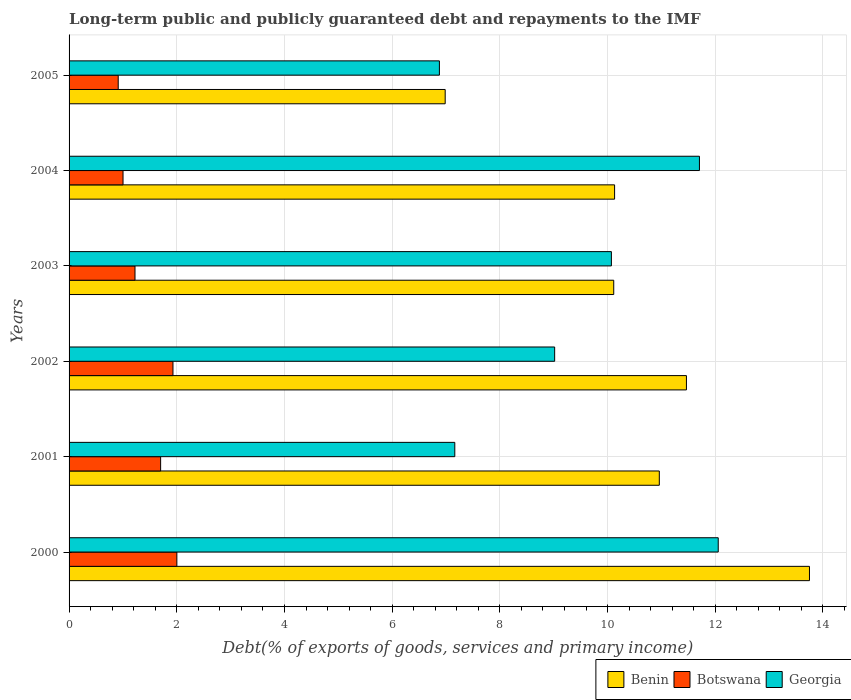How many groups of bars are there?
Ensure brevity in your answer.  6. Are the number of bars on each tick of the Y-axis equal?
Ensure brevity in your answer.  Yes. How many bars are there on the 3rd tick from the top?
Provide a succinct answer. 3. In how many cases, is the number of bars for a given year not equal to the number of legend labels?
Ensure brevity in your answer.  0. What is the debt and repayments in Botswana in 2004?
Provide a succinct answer. 1. Across all years, what is the maximum debt and repayments in Georgia?
Provide a short and direct response. 12.06. Across all years, what is the minimum debt and repayments in Benin?
Offer a very short reply. 6.99. What is the total debt and repayments in Botswana in the graph?
Provide a succinct answer. 8.77. What is the difference between the debt and repayments in Benin in 2004 and that in 2005?
Offer a very short reply. 3.15. What is the difference between the debt and repayments in Benin in 2000 and the debt and repayments in Botswana in 2002?
Ensure brevity in your answer.  11.82. What is the average debt and repayments in Georgia per year?
Offer a very short reply. 9.48. In the year 2003, what is the difference between the debt and repayments in Botswana and debt and repayments in Georgia?
Provide a short and direct response. -8.85. In how many years, is the debt and repayments in Botswana greater than 9.2 %?
Your answer should be very brief. 0. What is the ratio of the debt and repayments in Benin in 2000 to that in 2002?
Ensure brevity in your answer.  1.2. Is the debt and repayments in Georgia in 2003 less than that in 2005?
Provide a short and direct response. No. Is the difference between the debt and repayments in Botswana in 2002 and 2005 greater than the difference between the debt and repayments in Georgia in 2002 and 2005?
Make the answer very short. No. What is the difference between the highest and the second highest debt and repayments in Benin?
Ensure brevity in your answer.  2.28. What is the difference between the highest and the lowest debt and repayments in Botswana?
Your response must be concise. 1.09. What does the 2nd bar from the top in 2005 represents?
Provide a short and direct response. Botswana. What does the 1st bar from the bottom in 2000 represents?
Ensure brevity in your answer.  Benin. What is the difference between two consecutive major ticks on the X-axis?
Offer a terse response. 2. Does the graph contain any zero values?
Your response must be concise. No. Does the graph contain grids?
Provide a succinct answer. Yes. Where does the legend appear in the graph?
Your response must be concise. Bottom right. How many legend labels are there?
Make the answer very short. 3. How are the legend labels stacked?
Give a very brief answer. Horizontal. What is the title of the graph?
Keep it short and to the point. Long-term public and publicly guaranteed debt and repayments to the IMF. Does "Qatar" appear as one of the legend labels in the graph?
Your answer should be compact. No. What is the label or title of the X-axis?
Make the answer very short. Debt(% of exports of goods, services and primary income). What is the label or title of the Y-axis?
Your answer should be compact. Years. What is the Debt(% of exports of goods, services and primary income) of Benin in 2000?
Your answer should be very brief. 13.75. What is the Debt(% of exports of goods, services and primary income) in Botswana in 2000?
Keep it short and to the point. 2. What is the Debt(% of exports of goods, services and primary income) of Georgia in 2000?
Provide a succinct answer. 12.06. What is the Debt(% of exports of goods, services and primary income) in Benin in 2001?
Offer a very short reply. 10.96. What is the Debt(% of exports of goods, services and primary income) of Botswana in 2001?
Your answer should be compact. 1.7. What is the Debt(% of exports of goods, services and primary income) of Georgia in 2001?
Your response must be concise. 7.16. What is the Debt(% of exports of goods, services and primary income) in Benin in 2002?
Ensure brevity in your answer.  11.47. What is the Debt(% of exports of goods, services and primary income) in Botswana in 2002?
Give a very brief answer. 1.93. What is the Debt(% of exports of goods, services and primary income) in Georgia in 2002?
Keep it short and to the point. 9.02. What is the Debt(% of exports of goods, services and primary income) in Benin in 2003?
Your answer should be compact. 10.12. What is the Debt(% of exports of goods, services and primary income) of Botswana in 2003?
Make the answer very short. 1.22. What is the Debt(% of exports of goods, services and primary income) in Georgia in 2003?
Make the answer very short. 10.07. What is the Debt(% of exports of goods, services and primary income) of Benin in 2004?
Keep it short and to the point. 10.13. What is the Debt(% of exports of goods, services and primary income) of Botswana in 2004?
Give a very brief answer. 1. What is the Debt(% of exports of goods, services and primary income) of Georgia in 2004?
Provide a short and direct response. 11.71. What is the Debt(% of exports of goods, services and primary income) of Benin in 2005?
Offer a terse response. 6.99. What is the Debt(% of exports of goods, services and primary income) in Botswana in 2005?
Offer a very short reply. 0.91. What is the Debt(% of exports of goods, services and primary income) in Georgia in 2005?
Your response must be concise. 6.88. Across all years, what is the maximum Debt(% of exports of goods, services and primary income) of Benin?
Ensure brevity in your answer.  13.75. Across all years, what is the maximum Debt(% of exports of goods, services and primary income) of Botswana?
Offer a very short reply. 2. Across all years, what is the maximum Debt(% of exports of goods, services and primary income) of Georgia?
Keep it short and to the point. 12.06. Across all years, what is the minimum Debt(% of exports of goods, services and primary income) in Benin?
Provide a short and direct response. 6.99. Across all years, what is the minimum Debt(% of exports of goods, services and primary income) of Botswana?
Offer a very short reply. 0.91. Across all years, what is the minimum Debt(% of exports of goods, services and primary income) in Georgia?
Your response must be concise. 6.88. What is the total Debt(% of exports of goods, services and primary income) in Benin in the graph?
Ensure brevity in your answer.  63.41. What is the total Debt(% of exports of goods, services and primary income) in Botswana in the graph?
Your answer should be very brief. 8.77. What is the total Debt(% of exports of goods, services and primary income) in Georgia in the graph?
Provide a short and direct response. 56.89. What is the difference between the Debt(% of exports of goods, services and primary income) of Benin in 2000 and that in 2001?
Offer a very short reply. 2.79. What is the difference between the Debt(% of exports of goods, services and primary income) of Botswana in 2000 and that in 2001?
Make the answer very short. 0.3. What is the difference between the Debt(% of exports of goods, services and primary income) in Georgia in 2000 and that in 2001?
Offer a terse response. 4.89. What is the difference between the Debt(% of exports of goods, services and primary income) in Benin in 2000 and that in 2002?
Your answer should be very brief. 2.28. What is the difference between the Debt(% of exports of goods, services and primary income) in Botswana in 2000 and that in 2002?
Provide a succinct answer. 0.07. What is the difference between the Debt(% of exports of goods, services and primary income) in Georgia in 2000 and that in 2002?
Your answer should be compact. 3.04. What is the difference between the Debt(% of exports of goods, services and primary income) of Benin in 2000 and that in 2003?
Give a very brief answer. 3.63. What is the difference between the Debt(% of exports of goods, services and primary income) of Botswana in 2000 and that in 2003?
Offer a terse response. 0.78. What is the difference between the Debt(% of exports of goods, services and primary income) of Georgia in 2000 and that in 2003?
Give a very brief answer. 1.98. What is the difference between the Debt(% of exports of goods, services and primary income) in Benin in 2000 and that in 2004?
Keep it short and to the point. 3.62. What is the difference between the Debt(% of exports of goods, services and primary income) in Georgia in 2000 and that in 2004?
Provide a succinct answer. 0.35. What is the difference between the Debt(% of exports of goods, services and primary income) in Benin in 2000 and that in 2005?
Provide a succinct answer. 6.76. What is the difference between the Debt(% of exports of goods, services and primary income) of Botswana in 2000 and that in 2005?
Provide a succinct answer. 1.09. What is the difference between the Debt(% of exports of goods, services and primary income) in Georgia in 2000 and that in 2005?
Give a very brief answer. 5.18. What is the difference between the Debt(% of exports of goods, services and primary income) of Benin in 2001 and that in 2002?
Provide a succinct answer. -0.5. What is the difference between the Debt(% of exports of goods, services and primary income) in Botswana in 2001 and that in 2002?
Offer a terse response. -0.23. What is the difference between the Debt(% of exports of goods, services and primary income) in Georgia in 2001 and that in 2002?
Your answer should be compact. -1.85. What is the difference between the Debt(% of exports of goods, services and primary income) in Benin in 2001 and that in 2003?
Give a very brief answer. 0.85. What is the difference between the Debt(% of exports of goods, services and primary income) of Botswana in 2001 and that in 2003?
Keep it short and to the point. 0.48. What is the difference between the Debt(% of exports of goods, services and primary income) in Georgia in 2001 and that in 2003?
Your answer should be very brief. -2.91. What is the difference between the Debt(% of exports of goods, services and primary income) of Benin in 2001 and that in 2004?
Offer a very short reply. 0.83. What is the difference between the Debt(% of exports of goods, services and primary income) of Botswana in 2001 and that in 2004?
Your response must be concise. 0.7. What is the difference between the Debt(% of exports of goods, services and primary income) in Georgia in 2001 and that in 2004?
Offer a very short reply. -4.54. What is the difference between the Debt(% of exports of goods, services and primary income) in Benin in 2001 and that in 2005?
Provide a succinct answer. 3.98. What is the difference between the Debt(% of exports of goods, services and primary income) in Botswana in 2001 and that in 2005?
Your answer should be compact. 0.79. What is the difference between the Debt(% of exports of goods, services and primary income) in Georgia in 2001 and that in 2005?
Your answer should be very brief. 0.29. What is the difference between the Debt(% of exports of goods, services and primary income) in Benin in 2002 and that in 2003?
Give a very brief answer. 1.35. What is the difference between the Debt(% of exports of goods, services and primary income) of Botswana in 2002 and that in 2003?
Offer a terse response. 0.71. What is the difference between the Debt(% of exports of goods, services and primary income) in Georgia in 2002 and that in 2003?
Offer a terse response. -1.05. What is the difference between the Debt(% of exports of goods, services and primary income) of Benin in 2002 and that in 2004?
Your answer should be compact. 1.33. What is the difference between the Debt(% of exports of goods, services and primary income) of Botswana in 2002 and that in 2004?
Offer a terse response. 0.93. What is the difference between the Debt(% of exports of goods, services and primary income) in Georgia in 2002 and that in 2004?
Offer a terse response. -2.69. What is the difference between the Debt(% of exports of goods, services and primary income) in Benin in 2002 and that in 2005?
Your response must be concise. 4.48. What is the difference between the Debt(% of exports of goods, services and primary income) of Botswana in 2002 and that in 2005?
Your answer should be very brief. 1.02. What is the difference between the Debt(% of exports of goods, services and primary income) of Georgia in 2002 and that in 2005?
Keep it short and to the point. 2.14. What is the difference between the Debt(% of exports of goods, services and primary income) of Benin in 2003 and that in 2004?
Your answer should be very brief. -0.02. What is the difference between the Debt(% of exports of goods, services and primary income) in Botswana in 2003 and that in 2004?
Offer a very short reply. 0.22. What is the difference between the Debt(% of exports of goods, services and primary income) in Georgia in 2003 and that in 2004?
Offer a very short reply. -1.64. What is the difference between the Debt(% of exports of goods, services and primary income) in Benin in 2003 and that in 2005?
Offer a terse response. 3.13. What is the difference between the Debt(% of exports of goods, services and primary income) of Botswana in 2003 and that in 2005?
Your response must be concise. 0.31. What is the difference between the Debt(% of exports of goods, services and primary income) in Georgia in 2003 and that in 2005?
Offer a very short reply. 3.19. What is the difference between the Debt(% of exports of goods, services and primary income) of Benin in 2004 and that in 2005?
Provide a succinct answer. 3.15. What is the difference between the Debt(% of exports of goods, services and primary income) of Botswana in 2004 and that in 2005?
Provide a succinct answer. 0.09. What is the difference between the Debt(% of exports of goods, services and primary income) of Georgia in 2004 and that in 2005?
Ensure brevity in your answer.  4.83. What is the difference between the Debt(% of exports of goods, services and primary income) in Benin in 2000 and the Debt(% of exports of goods, services and primary income) in Botswana in 2001?
Keep it short and to the point. 12.05. What is the difference between the Debt(% of exports of goods, services and primary income) of Benin in 2000 and the Debt(% of exports of goods, services and primary income) of Georgia in 2001?
Keep it short and to the point. 6.59. What is the difference between the Debt(% of exports of goods, services and primary income) in Botswana in 2000 and the Debt(% of exports of goods, services and primary income) in Georgia in 2001?
Make the answer very short. -5.16. What is the difference between the Debt(% of exports of goods, services and primary income) of Benin in 2000 and the Debt(% of exports of goods, services and primary income) of Botswana in 2002?
Your response must be concise. 11.82. What is the difference between the Debt(% of exports of goods, services and primary income) in Benin in 2000 and the Debt(% of exports of goods, services and primary income) in Georgia in 2002?
Provide a short and direct response. 4.73. What is the difference between the Debt(% of exports of goods, services and primary income) in Botswana in 2000 and the Debt(% of exports of goods, services and primary income) in Georgia in 2002?
Your response must be concise. -7.02. What is the difference between the Debt(% of exports of goods, services and primary income) in Benin in 2000 and the Debt(% of exports of goods, services and primary income) in Botswana in 2003?
Offer a terse response. 12.53. What is the difference between the Debt(% of exports of goods, services and primary income) of Benin in 2000 and the Debt(% of exports of goods, services and primary income) of Georgia in 2003?
Provide a short and direct response. 3.68. What is the difference between the Debt(% of exports of goods, services and primary income) of Botswana in 2000 and the Debt(% of exports of goods, services and primary income) of Georgia in 2003?
Your answer should be compact. -8.07. What is the difference between the Debt(% of exports of goods, services and primary income) in Benin in 2000 and the Debt(% of exports of goods, services and primary income) in Botswana in 2004?
Provide a succinct answer. 12.75. What is the difference between the Debt(% of exports of goods, services and primary income) of Benin in 2000 and the Debt(% of exports of goods, services and primary income) of Georgia in 2004?
Your answer should be compact. 2.04. What is the difference between the Debt(% of exports of goods, services and primary income) of Botswana in 2000 and the Debt(% of exports of goods, services and primary income) of Georgia in 2004?
Make the answer very short. -9.71. What is the difference between the Debt(% of exports of goods, services and primary income) in Benin in 2000 and the Debt(% of exports of goods, services and primary income) in Botswana in 2005?
Make the answer very short. 12.84. What is the difference between the Debt(% of exports of goods, services and primary income) of Benin in 2000 and the Debt(% of exports of goods, services and primary income) of Georgia in 2005?
Provide a succinct answer. 6.87. What is the difference between the Debt(% of exports of goods, services and primary income) of Botswana in 2000 and the Debt(% of exports of goods, services and primary income) of Georgia in 2005?
Keep it short and to the point. -4.88. What is the difference between the Debt(% of exports of goods, services and primary income) of Benin in 2001 and the Debt(% of exports of goods, services and primary income) of Botswana in 2002?
Ensure brevity in your answer.  9.03. What is the difference between the Debt(% of exports of goods, services and primary income) in Benin in 2001 and the Debt(% of exports of goods, services and primary income) in Georgia in 2002?
Keep it short and to the point. 1.94. What is the difference between the Debt(% of exports of goods, services and primary income) of Botswana in 2001 and the Debt(% of exports of goods, services and primary income) of Georgia in 2002?
Keep it short and to the point. -7.32. What is the difference between the Debt(% of exports of goods, services and primary income) of Benin in 2001 and the Debt(% of exports of goods, services and primary income) of Botswana in 2003?
Your answer should be very brief. 9.74. What is the difference between the Debt(% of exports of goods, services and primary income) of Benin in 2001 and the Debt(% of exports of goods, services and primary income) of Georgia in 2003?
Give a very brief answer. 0.89. What is the difference between the Debt(% of exports of goods, services and primary income) in Botswana in 2001 and the Debt(% of exports of goods, services and primary income) in Georgia in 2003?
Give a very brief answer. -8.37. What is the difference between the Debt(% of exports of goods, services and primary income) in Benin in 2001 and the Debt(% of exports of goods, services and primary income) in Botswana in 2004?
Your answer should be compact. 9.96. What is the difference between the Debt(% of exports of goods, services and primary income) of Benin in 2001 and the Debt(% of exports of goods, services and primary income) of Georgia in 2004?
Make the answer very short. -0.75. What is the difference between the Debt(% of exports of goods, services and primary income) of Botswana in 2001 and the Debt(% of exports of goods, services and primary income) of Georgia in 2004?
Keep it short and to the point. -10.01. What is the difference between the Debt(% of exports of goods, services and primary income) in Benin in 2001 and the Debt(% of exports of goods, services and primary income) in Botswana in 2005?
Ensure brevity in your answer.  10.05. What is the difference between the Debt(% of exports of goods, services and primary income) of Benin in 2001 and the Debt(% of exports of goods, services and primary income) of Georgia in 2005?
Offer a very short reply. 4.08. What is the difference between the Debt(% of exports of goods, services and primary income) in Botswana in 2001 and the Debt(% of exports of goods, services and primary income) in Georgia in 2005?
Your response must be concise. -5.18. What is the difference between the Debt(% of exports of goods, services and primary income) of Benin in 2002 and the Debt(% of exports of goods, services and primary income) of Botswana in 2003?
Offer a very short reply. 10.24. What is the difference between the Debt(% of exports of goods, services and primary income) in Benin in 2002 and the Debt(% of exports of goods, services and primary income) in Georgia in 2003?
Ensure brevity in your answer.  1.39. What is the difference between the Debt(% of exports of goods, services and primary income) in Botswana in 2002 and the Debt(% of exports of goods, services and primary income) in Georgia in 2003?
Keep it short and to the point. -8.14. What is the difference between the Debt(% of exports of goods, services and primary income) of Benin in 2002 and the Debt(% of exports of goods, services and primary income) of Botswana in 2004?
Your answer should be compact. 10.46. What is the difference between the Debt(% of exports of goods, services and primary income) in Benin in 2002 and the Debt(% of exports of goods, services and primary income) in Georgia in 2004?
Provide a short and direct response. -0.24. What is the difference between the Debt(% of exports of goods, services and primary income) of Botswana in 2002 and the Debt(% of exports of goods, services and primary income) of Georgia in 2004?
Your answer should be compact. -9.78. What is the difference between the Debt(% of exports of goods, services and primary income) of Benin in 2002 and the Debt(% of exports of goods, services and primary income) of Botswana in 2005?
Offer a terse response. 10.55. What is the difference between the Debt(% of exports of goods, services and primary income) in Benin in 2002 and the Debt(% of exports of goods, services and primary income) in Georgia in 2005?
Your answer should be compact. 4.59. What is the difference between the Debt(% of exports of goods, services and primary income) in Botswana in 2002 and the Debt(% of exports of goods, services and primary income) in Georgia in 2005?
Your response must be concise. -4.95. What is the difference between the Debt(% of exports of goods, services and primary income) of Benin in 2003 and the Debt(% of exports of goods, services and primary income) of Botswana in 2004?
Provide a succinct answer. 9.11. What is the difference between the Debt(% of exports of goods, services and primary income) in Benin in 2003 and the Debt(% of exports of goods, services and primary income) in Georgia in 2004?
Provide a short and direct response. -1.59. What is the difference between the Debt(% of exports of goods, services and primary income) in Botswana in 2003 and the Debt(% of exports of goods, services and primary income) in Georgia in 2004?
Your answer should be very brief. -10.48. What is the difference between the Debt(% of exports of goods, services and primary income) of Benin in 2003 and the Debt(% of exports of goods, services and primary income) of Botswana in 2005?
Provide a succinct answer. 9.2. What is the difference between the Debt(% of exports of goods, services and primary income) of Benin in 2003 and the Debt(% of exports of goods, services and primary income) of Georgia in 2005?
Your response must be concise. 3.24. What is the difference between the Debt(% of exports of goods, services and primary income) in Botswana in 2003 and the Debt(% of exports of goods, services and primary income) in Georgia in 2005?
Your answer should be compact. -5.65. What is the difference between the Debt(% of exports of goods, services and primary income) of Benin in 2004 and the Debt(% of exports of goods, services and primary income) of Botswana in 2005?
Provide a succinct answer. 9.22. What is the difference between the Debt(% of exports of goods, services and primary income) in Benin in 2004 and the Debt(% of exports of goods, services and primary income) in Georgia in 2005?
Ensure brevity in your answer.  3.25. What is the difference between the Debt(% of exports of goods, services and primary income) in Botswana in 2004 and the Debt(% of exports of goods, services and primary income) in Georgia in 2005?
Your response must be concise. -5.88. What is the average Debt(% of exports of goods, services and primary income) of Benin per year?
Your answer should be compact. 10.57. What is the average Debt(% of exports of goods, services and primary income) in Botswana per year?
Provide a short and direct response. 1.46. What is the average Debt(% of exports of goods, services and primary income) of Georgia per year?
Ensure brevity in your answer.  9.48. In the year 2000, what is the difference between the Debt(% of exports of goods, services and primary income) of Benin and Debt(% of exports of goods, services and primary income) of Botswana?
Offer a terse response. 11.75. In the year 2000, what is the difference between the Debt(% of exports of goods, services and primary income) of Benin and Debt(% of exports of goods, services and primary income) of Georgia?
Your response must be concise. 1.69. In the year 2000, what is the difference between the Debt(% of exports of goods, services and primary income) of Botswana and Debt(% of exports of goods, services and primary income) of Georgia?
Give a very brief answer. -10.05. In the year 2001, what is the difference between the Debt(% of exports of goods, services and primary income) of Benin and Debt(% of exports of goods, services and primary income) of Botswana?
Offer a terse response. 9.26. In the year 2001, what is the difference between the Debt(% of exports of goods, services and primary income) in Benin and Debt(% of exports of goods, services and primary income) in Georgia?
Provide a succinct answer. 3.8. In the year 2001, what is the difference between the Debt(% of exports of goods, services and primary income) in Botswana and Debt(% of exports of goods, services and primary income) in Georgia?
Your answer should be compact. -5.46. In the year 2002, what is the difference between the Debt(% of exports of goods, services and primary income) in Benin and Debt(% of exports of goods, services and primary income) in Botswana?
Provide a succinct answer. 9.54. In the year 2002, what is the difference between the Debt(% of exports of goods, services and primary income) of Benin and Debt(% of exports of goods, services and primary income) of Georgia?
Provide a short and direct response. 2.45. In the year 2002, what is the difference between the Debt(% of exports of goods, services and primary income) of Botswana and Debt(% of exports of goods, services and primary income) of Georgia?
Your answer should be very brief. -7.09. In the year 2003, what is the difference between the Debt(% of exports of goods, services and primary income) of Benin and Debt(% of exports of goods, services and primary income) of Botswana?
Ensure brevity in your answer.  8.89. In the year 2003, what is the difference between the Debt(% of exports of goods, services and primary income) in Benin and Debt(% of exports of goods, services and primary income) in Georgia?
Make the answer very short. 0.04. In the year 2003, what is the difference between the Debt(% of exports of goods, services and primary income) of Botswana and Debt(% of exports of goods, services and primary income) of Georgia?
Keep it short and to the point. -8.85. In the year 2004, what is the difference between the Debt(% of exports of goods, services and primary income) in Benin and Debt(% of exports of goods, services and primary income) in Botswana?
Provide a succinct answer. 9.13. In the year 2004, what is the difference between the Debt(% of exports of goods, services and primary income) of Benin and Debt(% of exports of goods, services and primary income) of Georgia?
Provide a succinct answer. -1.58. In the year 2004, what is the difference between the Debt(% of exports of goods, services and primary income) of Botswana and Debt(% of exports of goods, services and primary income) of Georgia?
Your response must be concise. -10.7. In the year 2005, what is the difference between the Debt(% of exports of goods, services and primary income) in Benin and Debt(% of exports of goods, services and primary income) in Botswana?
Offer a terse response. 6.07. In the year 2005, what is the difference between the Debt(% of exports of goods, services and primary income) of Benin and Debt(% of exports of goods, services and primary income) of Georgia?
Make the answer very short. 0.11. In the year 2005, what is the difference between the Debt(% of exports of goods, services and primary income) of Botswana and Debt(% of exports of goods, services and primary income) of Georgia?
Ensure brevity in your answer.  -5.96. What is the ratio of the Debt(% of exports of goods, services and primary income) in Benin in 2000 to that in 2001?
Offer a very short reply. 1.25. What is the ratio of the Debt(% of exports of goods, services and primary income) of Botswana in 2000 to that in 2001?
Your answer should be compact. 1.18. What is the ratio of the Debt(% of exports of goods, services and primary income) in Georgia in 2000 to that in 2001?
Provide a short and direct response. 1.68. What is the ratio of the Debt(% of exports of goods, services and primary income) in Benin in 2000 to that in 2002?
Make the answer very short. 1.2. What is the ratio of the Debt(% of exports of goods, services and primary income) in Botswana in 2000 to that in 2002?
Your answer should be compact. 1.04. What is the ratio of the Debt(% of exports of goods, services and primary income) of Georgia in 2000 to that in 2002?
Your answer should be compact. 1.34. What is the ratio of the Debt(% of exports of goods, services and primary income) of Benin in 2000 to that in 2003?
Your response must be concise. 1.36. What is the ratio of the Debt(% of exports of goods, services and primary income) of Botswana in 2000 to that in 2003?
Keep it short and to the point. 1.63. What is the ratio of the Debt(% of exports of goods, services and primary income) in Georgia in 2000 to that in 2003?
Provide a succinct answer. 1.2. What is the ratio of the Debt(% of exports of goods, services and primary income) in Benin in 2000 to that in 2004?
Offer a very short reply. 1.36. What is the ratio of the Debt(% of exports of goods, services and primary income) of Botswana in 2000 to that in 2004?
Your answer should be very brief. 2. What is the ratio of the Debt(% of exports of goods, services and primary income) in Georgia in 2000 to that in 2004?
Your answer should be very brief. 1.03. What is the ratio of the Debt(% of exports of goods, services and primary income) in Benin in 2000 to that in 2005?
Offer a terse response. 1.97. What is the ratio of the Debt(% of exports of goods, services and primary income) in Botswana in 2000 to that in 2005?
Give a very brief answer. 2.19. What is the ratio of the Debt(% of exports of goods, services and primary income) of Georgia in 2000 to that in 2005?
Offer a terse response. 1.75. What is the ratio of the Debt(% of exports of goods, services and primary income) in Benin in 2001 to that in 2002?
Offer a very short reply. 0.96. What is the ratio of the Debt(% of exports of goods, services and primary income) in Botswana in 2001 to that in 2002?
Your response must be concise. 0.88. What is the ratio of the Debt(% of exports of goods, services and primary income) of Georgia in 2001 to that in 2002?
Make the answer very short. 0.79. What is the ratio of the Debt(% of exports of goods, services and primary income) of Benin in 2001 to that in 2003?
Give a very brief answer. 1.08. What is the ratio of the Debt(% of exports of goods, services and primary income) of Botswana in 2001 to that in 2003?
Provide a succinct answer. 1.39. What is the ratio of the Debt(% of exports of goods, services and primary income) in Georgia in 2001 to that in 2003?
Ensure brevity in your answer.  0.71. What is the ratio of the Debt(% of exports of goods, services and primary income) in Benin in 2001 to that in 2004?
Your answer should be compact. 1.08. What is the ratio of the Debt(% of exports of goods, services and primary income) in Botswana in 2001 to that in 2004?
Provide a short and direct response. 1.7. What is the ratio of the Debt(% of exports of goods, services and primary income) in Georgia in 2001 to that in 2004?
Your answer should be very brief. 0.61. What is the ratio of the Debt(% of exports of goods, services and primary income) of Benin in 2001 to that in 2005?
Your response must be concise. 1.57. What is the ratio of the Debt(% of exports of goods, services and primary income) in Botswana in 2001 to that in 2005?
Keep it short and to the point. 1.86. What is the ratio of the Debt(% of exports of goods, services and primary income) of Georgia in 2001 to that in 2005?
Provide a short and direct response. 1.04. What is the ratio of the Debt(% of exports of goods, services and primary income) of Benin in 2002 to that in 2003?
Give a very brief answer. 1.13. What is the ratio of the Debt(% of exports of goods, services and primary income) in Botswana in 2002 to that in 2003?
Provide a short and direct response. 1.58. What is the ratio of the Debt(% of exports of goods, services and primary income) in Georgia in 2002 to that in 2003?
Provide a short and direct response. 0.9. What is the ratio of the Debt(% of exports of goods, services and primary income) in Benin in 2002 to that in 2004?
Your answer should be compact. 1.13. What is the ratio of the Debt(% of exports of goods, services and primary income) of Botswana in 2002 to that in 2004?
Give a very brief answer. 1.93. What is the ratio of the Debt(% of exports of goods, services and primary income) of Georgia in 2002 to that in 2004?
Provide a succinct answer. 0.77. What is the ratio of the Debt(% of exports of goods, services and primary income) of Benin in 2002 to that in 2005?
Offer a very short reply. 1.64. What is the ratio of the Debt(% of exports of goods, services and primary income) in Botswana in 2002 to that in 2005?
Your response must be concise. 2.11. What is the ratio of the Debt(% of exports of goods, services and primary income) of Georgia in 2002 to that in 2005?
Offer a very short reply. 1.31. What is the ratio of the Debt(% of exports of goods, services and primary income) in Benin in 2003 to that in 2004?
Give a very brief answer. 1. What is the ratio of the Debt(% of exports of goods, services and primary income) in Botswana in 2003 to that in 2004?
Offer a very short reply. 1.22. What is the ratio of the Debt(% of exports of goods, services and primary income) of Georgia in 2003 to that in 2004?
Give a very brief answer. 0.86. What is the ratio of the Debt(% of exports of goods, services and primary income) in Benin in 2003 to that in 2005?
Your answer should be very brief. 1.45. What is the ratio of the Debt(% of exports of goods, services and primary income) of Botswana in 2003 to that in 2005?
Offer a terse response. 1.34. What is the ratio of the Debt(% of exports of goods, services and primary income) of Georgia in 2003 to that in 2005?
Make the answer very short. 1.46. What is the ratio of the Debt(% of exports of goods, services and primary income) of Benin in 2004 to that in 2005?
Ensure brevity in your answer.  1.45. What is the ratio of the Debt(% of exports of goods, services and primary income) in Botswana in 2004 to that in 2005?
Offer a terse response. 1.1. What is the ratio of the Debt(% of exports of goods, services and primary income) of Georgia in 2004 to that in 2005?
Keep it short and to the point. 1.7. What is the difference between the highest and the second highest Debt(% of exports of goods, services and primary income) of Benin?
Make the answer very short. 2.28. What is the difference between the highest and the second highest Debt(% of exports of goods, services and primary income) in Botswana?
Provide a short and direct response. 0.07. What is the difference between the highest and the second highest Debt(% of exports of goods, services and primary income) in Georgia?
Provide a succinct answer. 0.35. What is the difference between the highest and the lowest Debt(% of exports of goods, services and primary income) of Benin?
Make the answer very short. 6.76. What is the difference between the highest and the lowest Debt(% of exports of goods, services and primary income) in Botswana?
Offer a terse response. 1.09. What is the difference between the highest and the lowest Debt(% of exports of goods, services and primary income) in Georgia?
Offer a terse response. 5.18. 